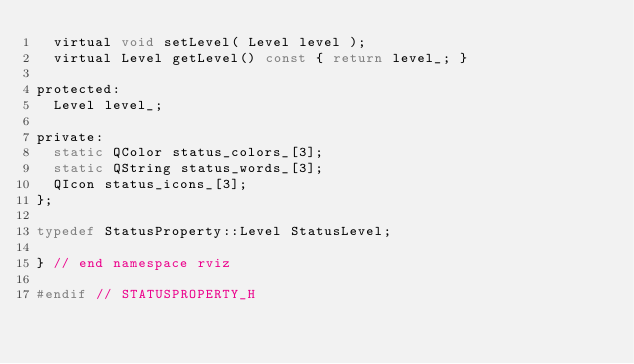<code> <loc_0><loc_0><loc_500><loc_500><_C_>  virtual void setLevel( Level level );
  virtual Level getLevel() const { return level_; }

protected:
  Level level_;

private:
  static QColor status_colors_[3];
  static QString status_words_[3];
  QIcon status_icons_[3];
};

typedef StatusProperty::Level StatusLevel;

} // end namespace rviz

#endif // STATUSPROPERTY_H
</code> 